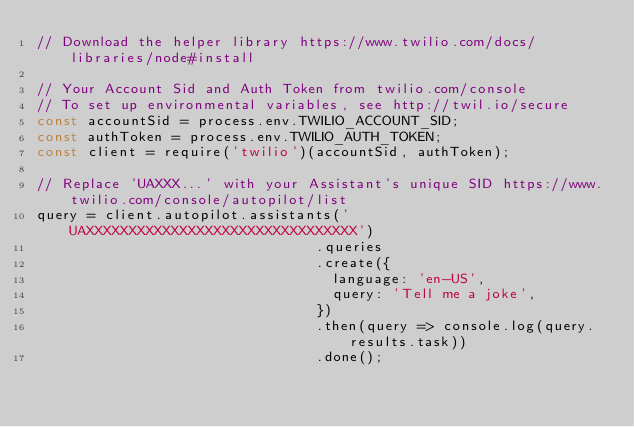Convert code to text. <code><loc_0><loc_0><loc_500><loc_500><_JavaScript_>// Download the helper library https://www.twilio.com/docs/libraries/node#install

// Your Account Sid and Auth Token from twilio.com/console
// To set up environmental variables, see http://twil.io/secure
const accountSid = process.env.TWILIO_ACCOUNT_SID;
const authToken = process.env.TWILIO_AUTH_TOKEN;
const client = require('twilio')(accountSid, authToken);

// Replace 'UAXXX...' with your Assistant's unique SID https://www.twilio.com/console/autopilot/list
query = client.autopilot.assistants('UAXXXXXXXXXXXXXXXXXXXXXXXXXXXXXXXX')
                                 .queries
                                 .create({
                                   language: 'en-US',
                                   query: 'Tell me a joke',
                                 })
                                 .then(query => console.log(query.results.task))
                                 .done();
</code> 